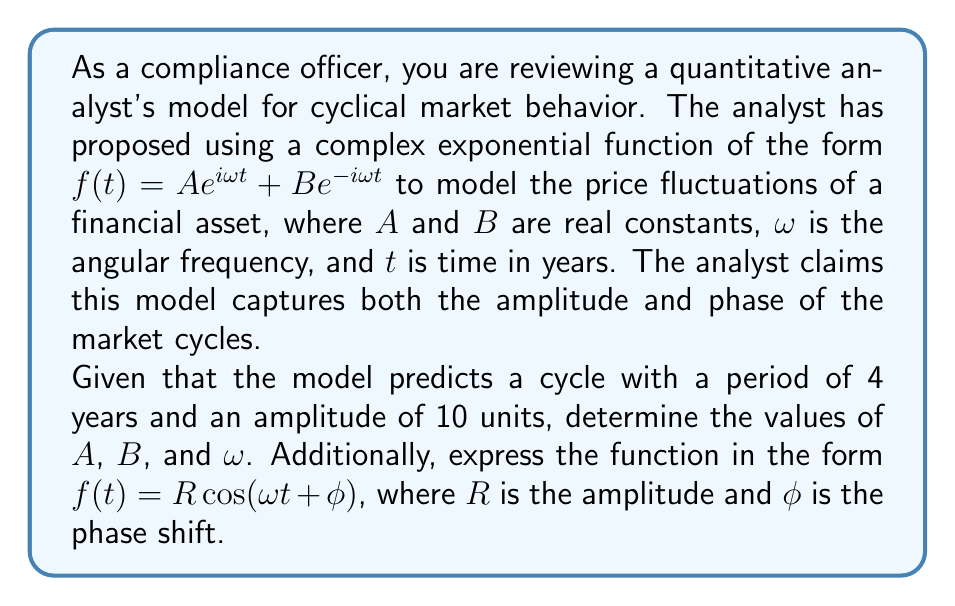Could you help me with this problem? Let's approach this step-by-step:

1) First, we need to determine $\omega$. The period $T$ is given as 4 years, and we know that $\omega = \frac{2\pi}{T}$. Therefore:

   $\omega = \frac{2\pi}{4} = \frac{\pi}{2}$ radians per year

2) The amplitude is given as 10 units. In the complex exponential form $f(t) = Ae^{i\omega t} + Be^{-i\omega t}$, the amplitude $R$ is equal to $|A+B|$ when $A$ and $B$ are real.

3) To simplify our model, let's assume $A = B = \frac{R}{2} = 5$. This ensures that the function is real-valued and has the correct amplitude.

4) Now we have:

   $f(t) = 5e^{i\frac{\pi}{2}t} + 5e^{-i\frac{\pi}{2}t}$

5) To convert this to the form $R\cos(\omega t + \phi)$, we can use Euler's formula:

   $e^{ix} + e^{-ix} = 2\cos(x)$

6) Applying this to our function:

   $f(t) = 5(e^{i\frac{\pi}{2}t} + e^{-i\frac{\pi}{2}t}) = 10\cos(\frac{\pi}{2}t)$

7) Comparing this with the general form $R\cos(\omega t + \phi)$, we can see that:
   
   $R = 10$
   $\omega = \frac{\pi}{2}$
   $\phi = 0$

Thus, we have successfully expressed the function in both forms.
Answer: $A = B = 5$
$\omega = \frac{\pi}{2}$ radians per year
$f(t) = 10\cos(\frac{\pi}{2}t)$ 